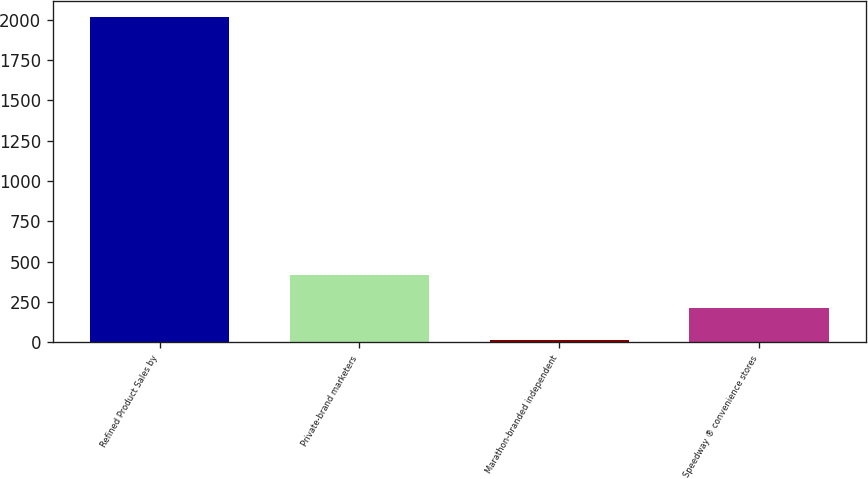Convert chart to OTSL. <chart><loc_0><loc_0><loc_500><loc_500><bar_chart><fcel>Refined Product Sales by<fcel>Private-brand marketers<fcel>Marathon-branded independent<fcel>Speedway ® convenience stores<nl><fcel>2015<fcel>414.2<fcel>14<fcel>214.1<nl></chart> 